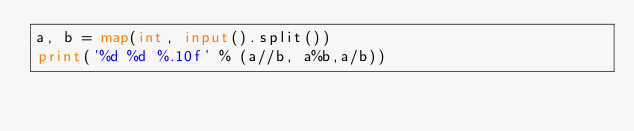Convert code to text. <code><loc_0><loc_0><loc_500><loc_500><_Python_>a, b = map(int, input().split())
print('%d %d %.10f' % (a//b, a%b,a/b))

</code> 